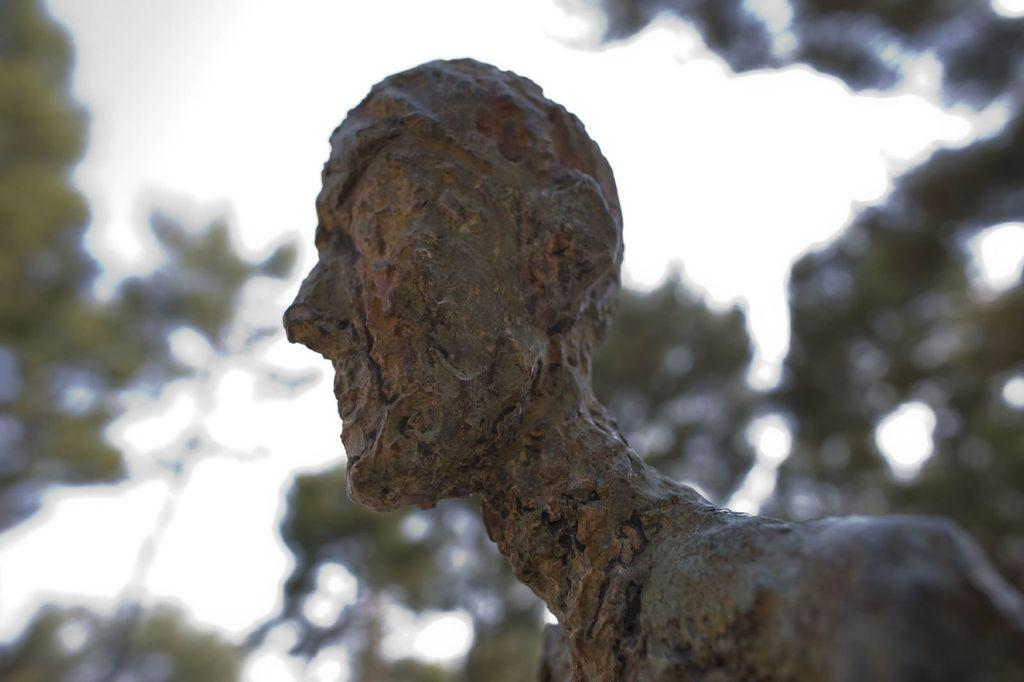What is the main subject of the image? There is a statue in the image. Can you describe the background of the image? The background of the image is blurred. What type of smell can be detected from the statue in the image? There is no information about any smell in the image, as it only features a statue and a blurred background. 